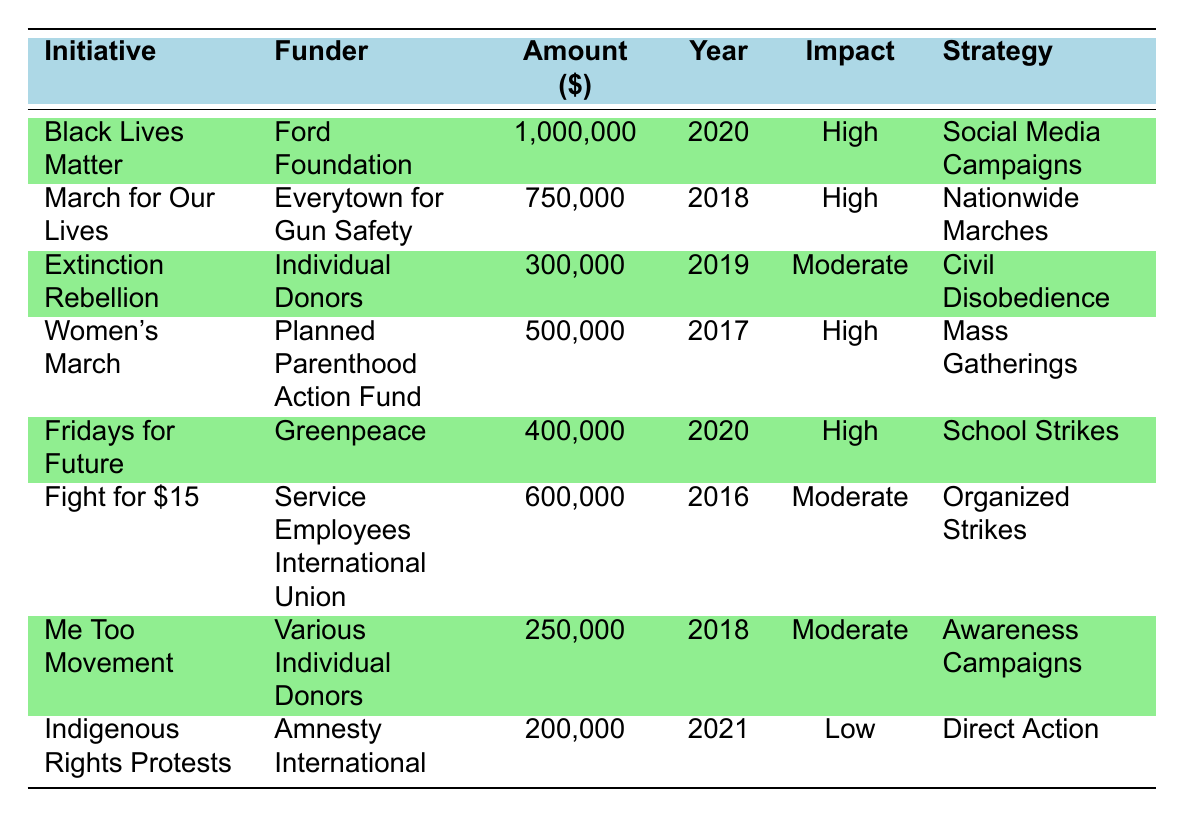What is the maximum amount funded for a protest initiative? The highest funding amount in the table is found under the "Black Lives Matter Movement," which received 1,000,000 dollars.
Answer: 1,000,000 Which protest initiative received the lowest amount of funding? The "Indigenous Rights Protests" received the lowest funding of 200,000 dollars, as indicated in the Amount column.
Answer: Indigenous Rights Protests How many protest initiatives had a High impact level? There are four initiatives marked with a High impact level: "Black Lives Matter Movement," "March for Our Lives," "Women’s March," and "Fridays for Future."
Answer: 4 What is the total funding amount for initiatives with a Moderate impact level? To find this, we add the funding amounts for initiatives with Moderate impact levels: "Extinction Rebellion" (300,000) + "Fight for $15" (600,000) + "Me Too Movement" (250,000) = 1,150,000 dollars.
Answer: 1,150,000 Did any protest initiative funded by Individual Donors have a High impact level? Upon examining the table, "Extinction Rebellion," funded by Individual Donors, is classified with a Moderate impact level, indicating no initiatives financed by Individual Donors achieved a High level.
Answer: No Which protest strategy had the highest funding amount associated with it? The "Social Media Campaigns" strategy of the "Black Lives Matter Movement" received the most funding at 1,000,000 dollars.
Answer: Social Media Campaigns What funding amount is associated with the "Fridays for Future" initiative? The funding amount listed for the "Fridays for Future" initiative is 400,000 dollars, as per the table data.
Answer: 400,000 Is there any protest initiative with an impact level lower than Moderate? Yes, the "Indigenous Rights Protests" is classified with a Low impact level, which is indeed lower than Moderate.
Answer: Yes How does the total funding of High impact initiatives compare to those with a Low impact? High impact initiatives receive a total of 2,850,000 dollars ("Black Lives Matter Movement" (1,000,000) + "March for Our Lives" (750,000) + "Women’s March" (500,000) + "Fridays for Future" (400,000)). The Low impact initiative, "Indigenous Rights Protests," has 200,000 dollars. Therefore, the High impact amount significantly exceeds the Low impact amount.
Answer: High impact exceeds Low impact Which year had the highest total funding across all initiatives? The year 2020 had two initiatives funded: "Black Lives Matter Movement" (1,000,000) and "Fridays for Future" (400,000), summing up to 1,400,000 dollars, which is the highest total compared to other years.
Answer: 2020 